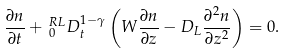Convert formula to latex. <formula><loc_0><loc_0><loc_500><loc_500>\frac { \partial n } { \partial t } + \, _ { 0 } ^ { R L } D _ { t } ^ { 1 - \gamma } \left ( W \frac { \partial n } { \partial z } - D _ { L } \frac { \partial ^ { 2 } n } { \partial z ^ { 2 } } \right ) = 0 .</formula> 